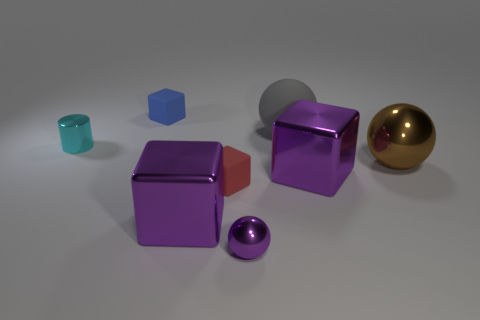Are there the same number of tiny shiny cylinders right of the gray matte sphere and cubes that are to the left of the small red matte cube?
Ensure brevity in your answer.  No. What number of big shiny blocks have the same color as the small metallic sphere?
Offer a very short reply. 2. How many metal things are either large blue spheres or spheres?
Give a very brief answer. 2. There is a cyan metallic object that is in front of the tiny blue rubber thing; does it have the same shape as the small metal object that is in front of the large brown ball?
Ensure brevity in your answer.  No. There is a red thing; how many metal cubes are behind it?
Offer a terse response. 1. Is there a tiny ball made of the same material as the large gray sphere?
Your answer should be compact. No. There is a brown sphere that is the same size as the gray sphere; what is its material?
Your answer should be compact. Metal. Is the material of the tiny purple sphere the same as the big gray sphere?
Offer a very short reply. No. What number of objects are tiny purple spheres or small cyan objects?
Make the answer very short. 2. What shape is the matte thing that is right of the tiny red rubber object?
Your answer should be compact. Sphere. 